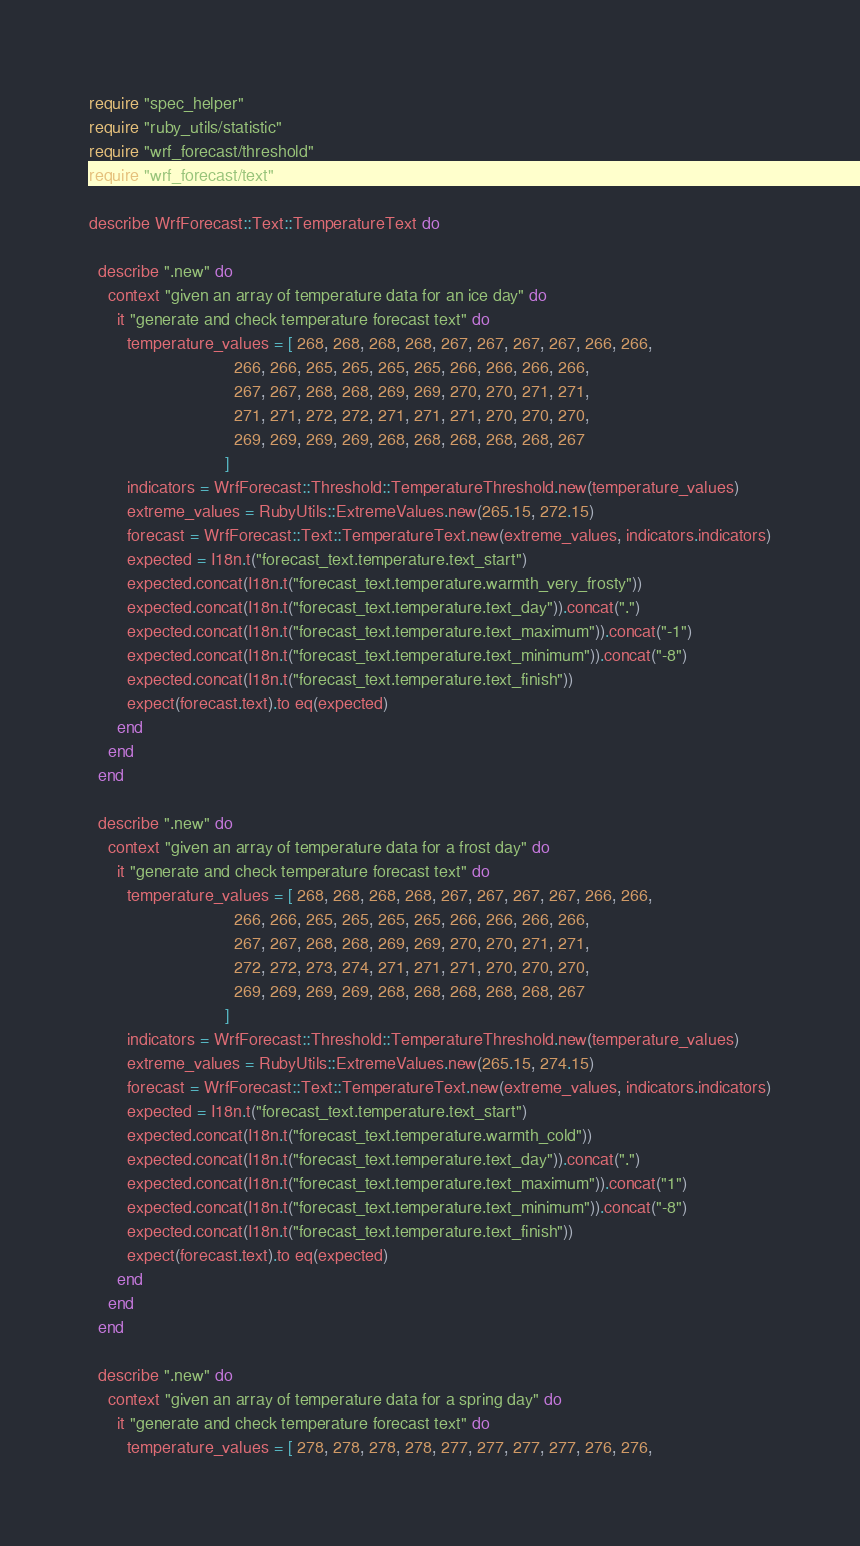<code> <loc_0><loc_0><loc_500><loc_500><_Ruby_>require "spec_helper"
require "ruby_utils/statistic"
require "wrf_forecast/threshold"
require "wrf_forecast/text"

describe WrfForecast::Text::TemperatureText do

  describe ".new" do
    context "given an array of temperature data for an ice day" do
      it "generate and check temperature forecast text" do
        temperature_values = [ 268, 268, 268, 268, 267, 267, 267, 267, 266, 266, 
                               266, 266, 265, 265, 265, 265, 266, 266, 266, 266,
                               267, 267, 268, 268, 269, 269, 270, 270, 271, 271, 
                               271, 271, 272, 272, 271, 271, 271, 270, 270, 270,
                               269, 269, 269, 269, 268, 268, 268, 268, 268, 267
                             ]
        indicators = WrfForecast::Threshold::TemperatureThreshold.new(temperature_values)
        extreme_values = RubyUtils::ExtremeValues.new(265.15, 272.15)
        forecast = WrfForecast::Text::TemperatureText.new(extreme_values, indicators.indicators)
        expected = I18n.t("forecast_text.temperature.text_start")
        expected.concat(I18n.t("forecast_text.temperature.warmth_very_frosty"))
        expected.concat(I18n.t("forecast_text.temperature.text_day")).concat(".")
        expected.concat(I18n.t("forecast_text.temperature.text_maximum")).concat("-1")
        expected.concat(I18n.t("forecast_text.temperature.text_minimum")).concat("-8")
        expected.concat(I18n.t("forecast_text.temperature.text_finish"))
        expect(forecast.text).to eq(expected)
      end
    end
  end

  describe ".new" do
    context "given an array of temperature data for a frost day" do
      it "generate and check temperature forecast text" do
        temperature_values = [ 268, 268, 268, 268, 267, 267, 267, 267, 266, 266, 
                               266, 266, 265, 265, 265, 265, 266, 266, 266, 266,
                               267, 267, 268, 268, 269, 269, 270, 270, 271, 271, 
                               272, 272, 273, 274, 271, 271, 271, 270, 270, 270,
                               269, 269, 269, 269, 268, 268, 268, 268, 268, 267
                             ]
        indicators = WrfForecast::Threshold::TemperatureThreshold.new(temperature_values)
        extreme_values = RubyUtils::ExtremeValues.new(265.15, 274.15)
        forecast = WrfForecast::Text::TemperatureText.new(extreme_values, indicators.indicators)
        expected = I18n.t("forecast_text.temperature.text_start")
        expected.concat(I18n.t("forecast_text.temperature.warmth_cold"))
        expected.concat(I18n.t("forecast_text.temperature.text_day")).concat(".")
        expected.concat(I18n.t("forecast_text.temperature.text_maximum")).concat("1")
        expected.concat(I18n.t("forecast_text.temperature.text_minimum")).concat("-8")
        expected.concat(I18n.t("forecast_text.temperature.text_finish"))
        expect(forecast.text).to eq(expected)
      end
    end
  end

  describe ".new" do
    context "given an array of temperature data for a spring day" do
      it "generate and check temperature forecast text" do
        temperature_values = [ 278, 278, 278, 278, 277, 277, 277, 277, 276, 276, </code> 